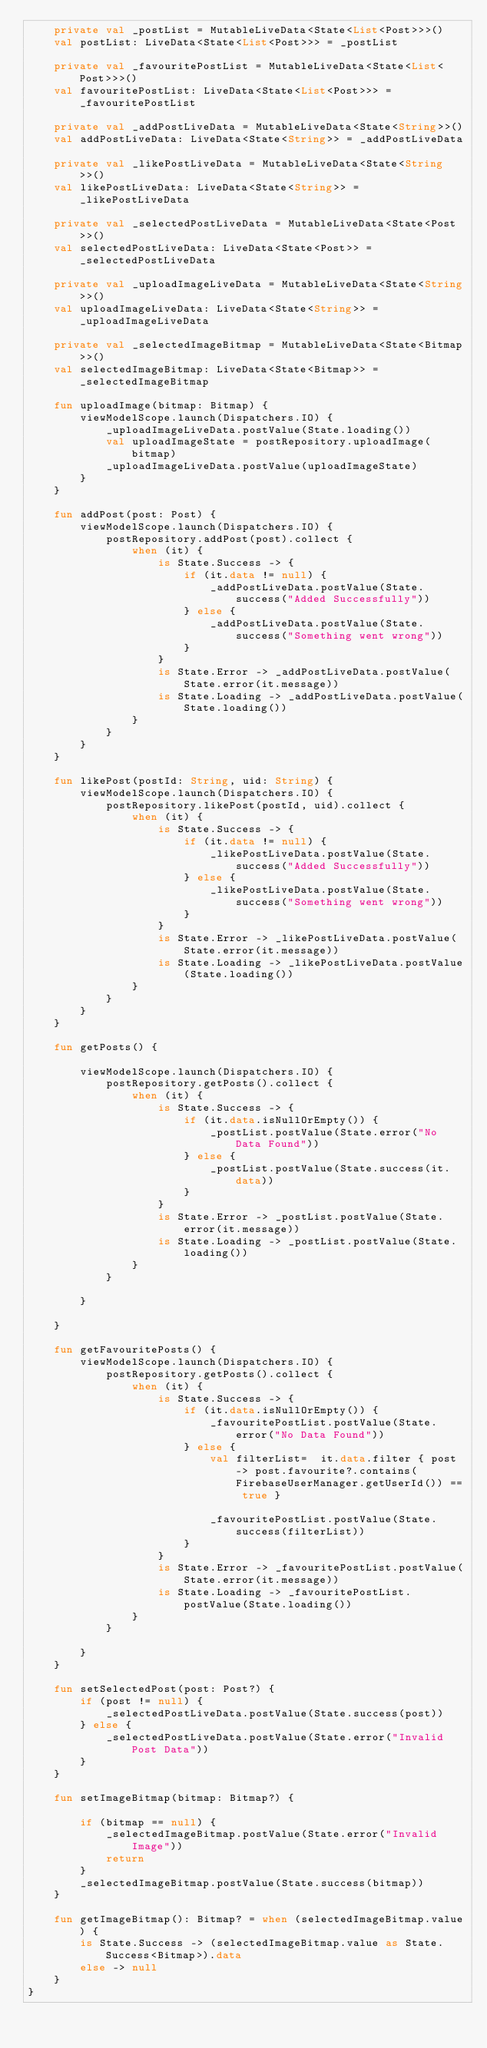<code> <loc_0><loc_0><loc_500><loc_500><_Kotlin_>    private val _postList = MutableLiveData<State<List<Post>>>()
    val postList: LiveData<State<List<Post>>> = _postList

    private val _favouritePostList = MutableLiveData<State<List<Post>>>()
    val favouritePostList: LiveData<State<List<Post>>> = _favouritePostList

    private val _addPostLiveData = MutableLiveData<State<String>>()
    val addPostLiveData: LiveData<State<String>> = _addPostLiveData

    private val _likePostLiveData = MutableLiveData<State<String>>()
    val likePostLiveData: LiveData<State<String>> = _likePostLiveData

    private val _selectedPostLiveData = MutableLiveData<State<Post>>()
    val selectedPostLiveData: LiveData<State<Post>> = _selectedPostLiveData

    private val _uploadImageLiveData = MutableLiveData<State<String>>()
    val uploadImageLiveData: LiveData<State<String>> = _uploadImageLiveData

    private val _selectedImageBitmap = MutableLiveData<State<Bitmap>>()
    val selectedImageBitmap: LiveData<State<Bitmap>> = _selectedImageBitmap

    fun uploadImage(bitmap: Bitmap) {
        viewModelScope.launch(Dispatchers.IO) {
            _uploadImageLiveData.postValue(State.loading())
            val uploadImageState = postRepository.uploadImage(bitmap)
            _uploadImageLiveData.postValue(uploadImageState)
        }
    }

    fun addPost(post: Post) {
        viewModelScope.launch(Dispatchers.IO) {
            postRepository.addPost(post).collect {
                when (it) {
                    is State.Success -> {
                        if (it.data != null) {
                            _addPostLiveData.postValue(State.success("Added Successfully"))
                        } else {
                            _addPostLiveData.postValue(State.success("Something went wrong"))
                        }
                    }
                    is State.Error -> _addPostLiveData.postValue(State.error(it.message))
                    is State.Loading -> _addPostLiveData.postValue(State.loading())
                }
            }
        }
    }

    fun likePost(postId: String, uid: String) {
        viewModelScope.launch(Dispatchers.IO) {
            postRepository.likePost(postId, uid).collect {
                when (it) {
                    is State.Success -> {
                        if (it.data != null) {
                            _likePostLiveData.postValue(State.success("Added Successfully"))
                        } else {
                            _likePostLiveData.postValue(State.success("Something went wrong"))
                        }
                    }
                    is State.Error -> _likePostLiveData.postValue(State.error(it.message))
                    is State.Loading -> _likePostLiveData.postValue(State.loading())
                }
            }
        }
    }

    fun getPosts() {

        viewModelScope.launch(Dispatchers.IO) {
            postRepository.getPosts().collect {
                when (it) {
                    is State.Success -> {
                        if (it.data.isNullOrEmpty()) {
                            _postList.postValue(State.error("No Data Found"))
                        } else {
                            _postList.postValue(State.success(it.data))
                        }
                    }
                    is State.Error -> _postList.postValue(State.error(it.message))
                    is State.Loading -> _postList.postValue(State.loading())
                }
            }

        }

    }

    fun getFavouritePosts() {
        viewModelScope.launch(Dispatchers.IO) {
            postRepository.getPosts().collect {
                when (it) {
                    is State.Success -> {
                        if (it.data.isNullOrEmpty()) {
                            _favouritePostList.postValue(State.error("No Data Found"))
                        } else {
                            val filterList=  it.data.filter { post -> post.favourite?.contains(FirebaseUserManager.getUserId()) == true }

                            _favouritePostList.postValue(State.success(filterList))
                        }
                    }
                    is State.Error -> _favouritePostList.postValue(State.error(it.message))
                    is State.Loading -> _favouritePostList.postValue(State.loading())
                }
            }

        }
    }

    fun setSelectedPost(post: Post?) {
        if (post != null) {
            _selectedPostLiveData.postValue(State.success(post))
        } else {
            _selectedPostLiveData.postValue(State.error("Invalid Post Data"))
        }
    }

    fun setImageBitmap(bitmap: Bitmap?) {

        if (bitmap == null) {
            _selectedImageBitmap.postValue(State.error("Invalid Image"))
            return
        }
        _selectedImageBitmap.postValue(State.success(bitmap))
    }

    fun getImageBitmap(): Bitmap? = when (selectedImageBitmap.value) {
        is State.Success -> (selectedImageBitmap.value as State.Success<Bitmap>).data
        else -> null
    }
}</code> 